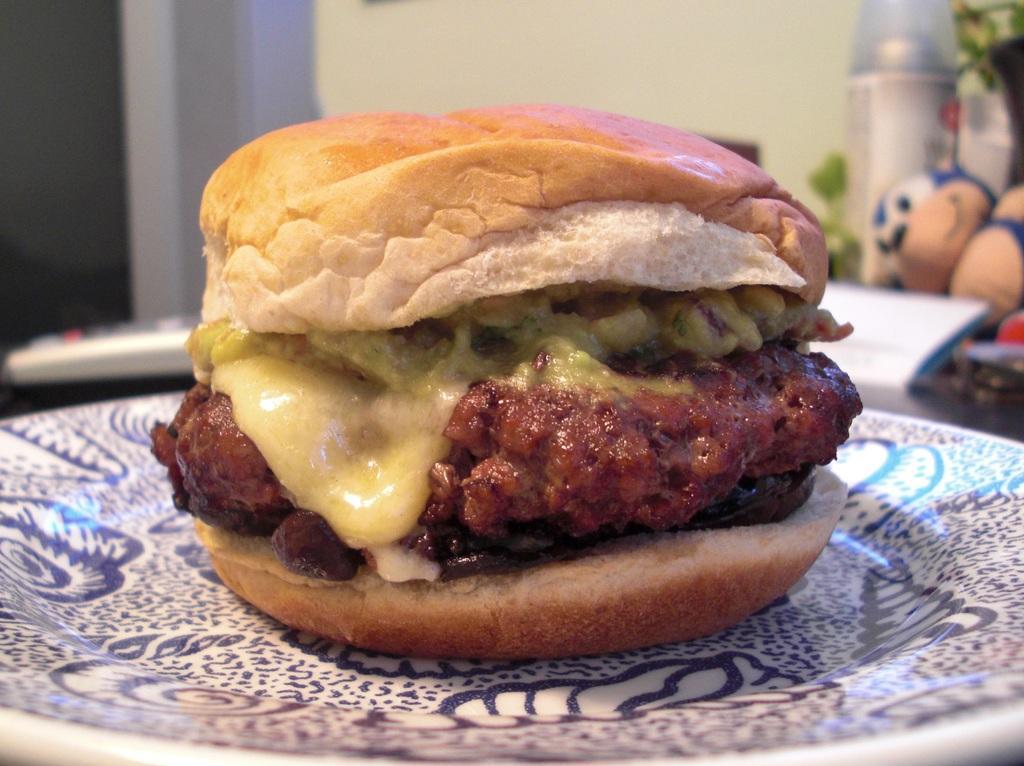Could you give a brief overview of what you see in this image? In this image there is a burger place on the plate and we can see a remote, soft toy and some objects placed on the table. In the background there is a wall. 